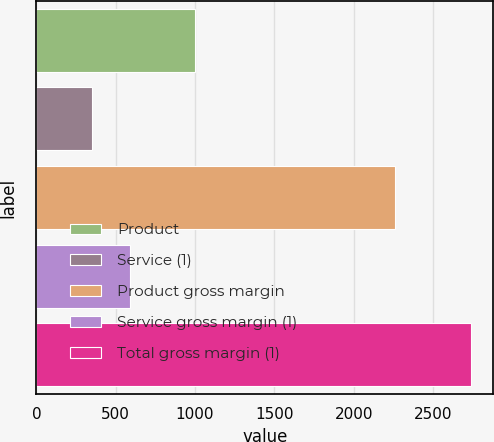Convert chart to OTSL. <chart><loc_0><loc_0><loc_500><loc_500><bar_chart><fcel>Product<fcel>Service (1)<fcel>Product gross margin<fcel>Service gross margin (1)<fcel>Total gross margin (1)<nl><fcel>1000.9<fcel>350.6<fcel>2257.8<fcel>589.72<fcel>2741.8<nl></chart> 